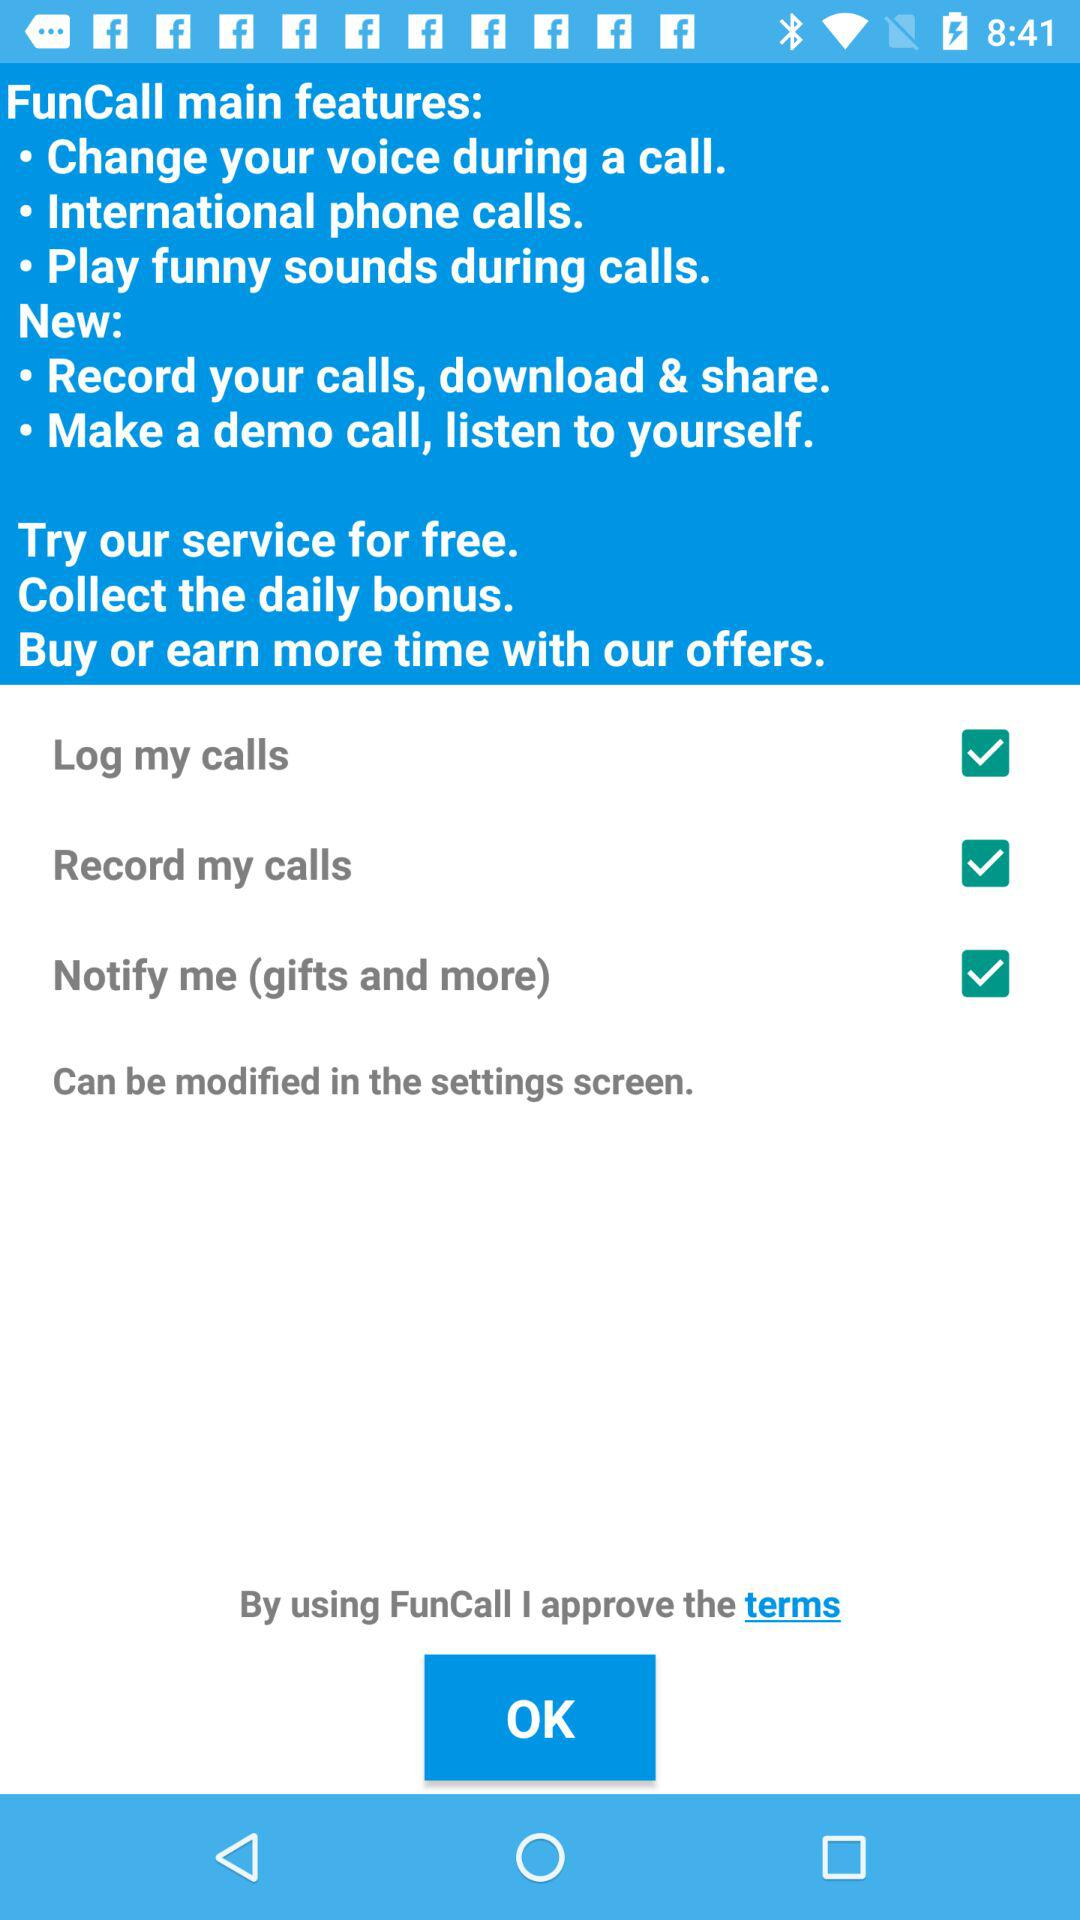What is the status of "Record my calls"? The status of "Record my calls" is "on". 